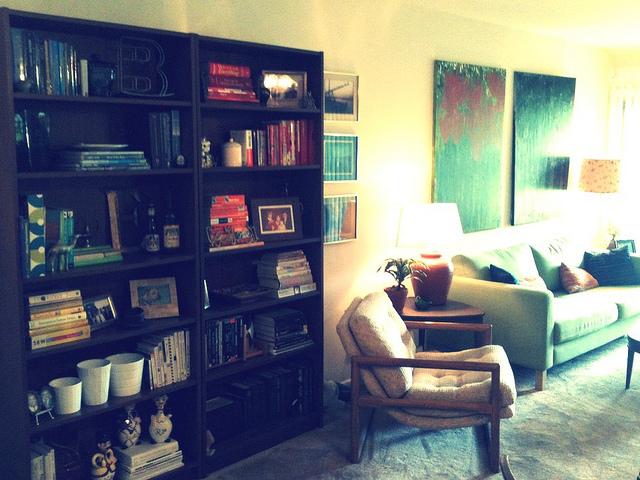What is the wall's color?
Give a very brief answer. Yellow. How many paintings on the wall?
Answer briefly. 5. What letter is on the bookshelf?
Answer briefly. B. 